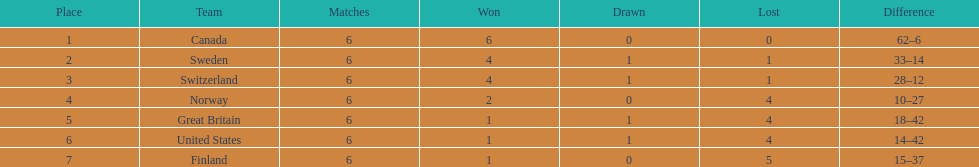In which nation did the united states rank higher than? Finland. 